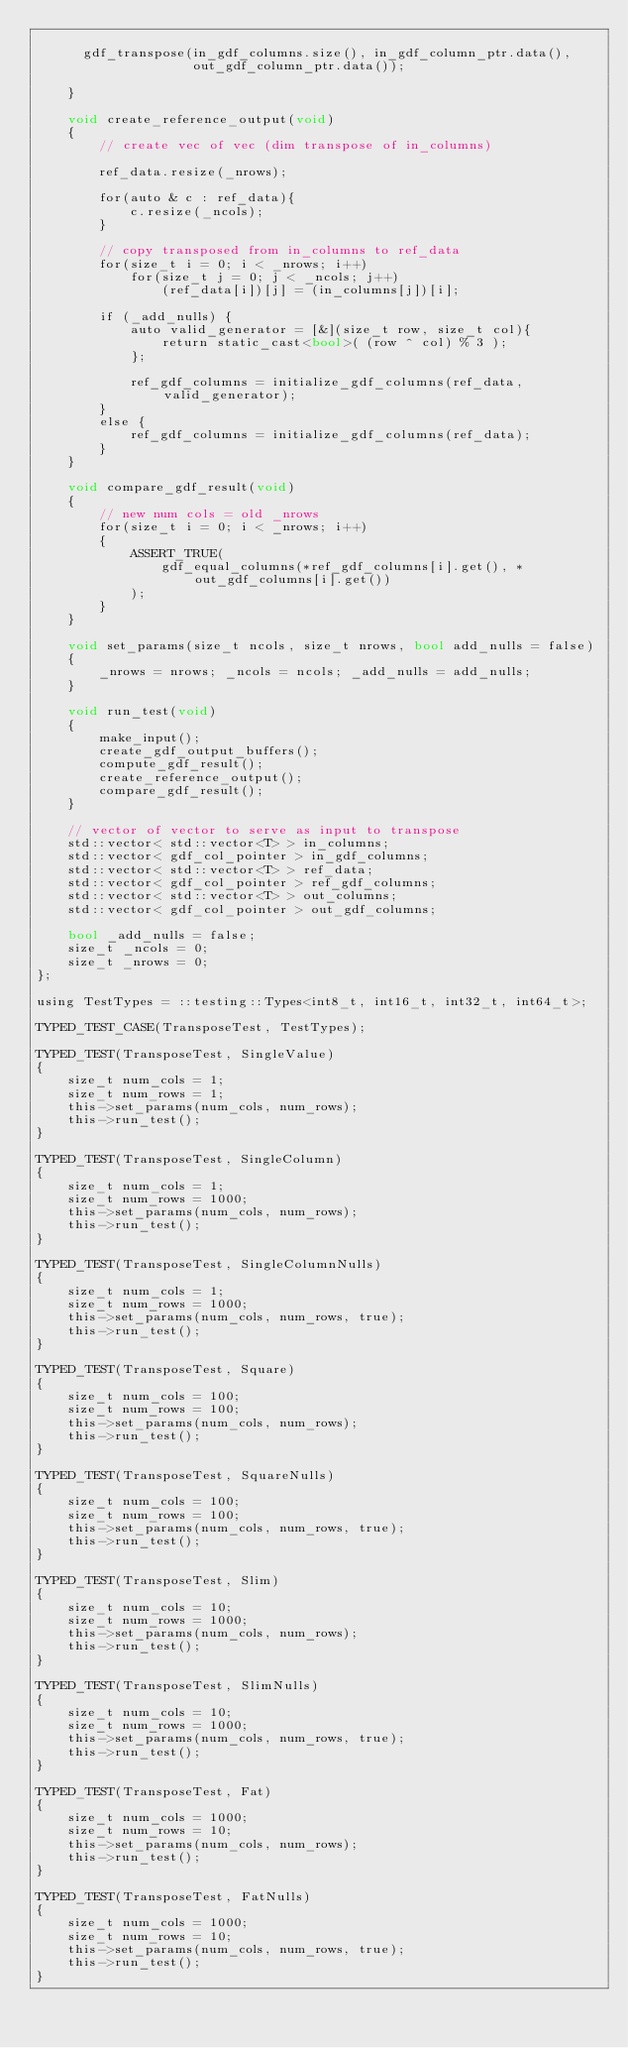<code> <loc_0><loc_0><loc_500><loc_500><_Cuda_>
      gdf_transpose(in_gdf_columns.size(), in_gdf_column_ptr.data(),
                    out_gdf_column_ptr.data());

    }

    void create_reference_output(void)
    {
        // create vec of vec (dim transpose of in_columns)

        ref_data.resize(_nrows);

        for(auto & c : ref_data){
            c.resize(_ncols);
        }

        // copy transposed from in_columns to ref_data
        for(size_t i = 0; i < _nrows; i++)
            for(size_t j = 0; j < _ncols; j++)
                (ref_data[i])[j] = (in_columns[j])[i];
        
        if (_add_nulls) {
            auto valid_generator = [&](size_t row, size_t col){
                return static_cast<bool>( (row ^ col) % 3 );
            };

            ref_gdf_columns = initialize_gdf_columns(ref_data, valid_generator);
        }
        else {
            ref_gdf_columns = initialize_gdf_columns(ref_data);
        }
    }

    void compare_gdf_result(void)
    {
        // new num cols = old _nrows
        for(size_t i = 0; i < _nrows; i++)
        {
            ASSERT_TRUE(
                gdf_equal_columns(*ref_gdf_columns[i].get(), *out_gdf_columns[i].get())
            );
        }
    }

    void set_params(size_t ncols, size_t nrows, bool add_nulls = false)
    {
        _nrows = nrows; _ncols = ncols; _add_nulls = add_nulls;
    }

    void run_test(void)
    {
        make_input();
        create_gdf_output_buffers();
        compute_gdf_result();
        create_reference_output();
        compare_gdf_result();
    }

    // vector of vector to serve as input to transpose
    std::vector< std::vector<T> > in_columns;
    std::vector< gdf_col_pointer > in_gdf_columns;
    std::vector< std::vector<T> > ref_data;
    std::vector< gdf_col_pointer > ref_gdf_columns;
    std::vector< std::vector<T> > out_columns;
    std::vector< gdf_col_pointer > out_gdf_columns;

    bool _add_nulls = false;
    size_t _ncols = 0;
    size_t _nrows = 0;
};

using TestTypes = ::testing::Types<int8_t, int16_t, int32_t, int64_t>;

TYPED_TEST_CASE(TransposeTest, TestTypes);

TYPED_TEST(TransposeTest, SingleValue)
{
    size_t num_cols = 1;
    size_t num_rows = 1;
    this->set_params(num_cols, num_rows);
    this->run_test();
}

TYPED_TEST(TransposeTest, SingleColumn)
{
    size_t num_cols = 1;
    size_t num_rows = 1000;
    this->set_params(num_cols, num_rows);
    this->run_test();
}

TYPED_TEST(TransposeTest, SingleColumnNulls)
{
    size_t num_cols = 1;
    size_t num_rows = 1000;
    this->set_params(num_cols, num_rows, true);
    this->run_test();
}

TYPED_TEST(TransposeTest, Square)
{
    size_t num_cols = 100;
    size_t num_rows = 100;
    this->set_params(num_cols, num_rows);
    this->run_test();
}

TYPED_TEST(TransposeTest, SquareNulls)
{
    size_t num_cols = 100;
    size_t num_rows = 100;
    this->set_params(num_cols, num_rows, true);
    this->run_test();
}

TYPED_TEST(TransposeTest, Slim)
{
    size_t num_cols = 10;
    size_t num_rows = 1000;
    this->set_params(num_cols, num_rows);
    this->run_test();
}

TYPED_TEST(TransposeTest, SlimNulls)
{
    size_t num_cols = 10;
    size_t num_rows = 1000;
    this->set_params(num_cols, num_rows, true);
    this->run_test();
}

TYPED_TEST(TransposeTest, Fat)
{
    size_t num_cols = 1000;
    size_t num_rows = 10;
    this->set_params(num_cols, num_rows);
    this->run_test();
}

TYPED_TEST(TransposeTest, FatNulls)
{
    size_t num_cols = 1000;
    size_t num_rows = 10;
    this->set_params(num_cols, num_rows, true);
    this->run_test();
}
</code> 